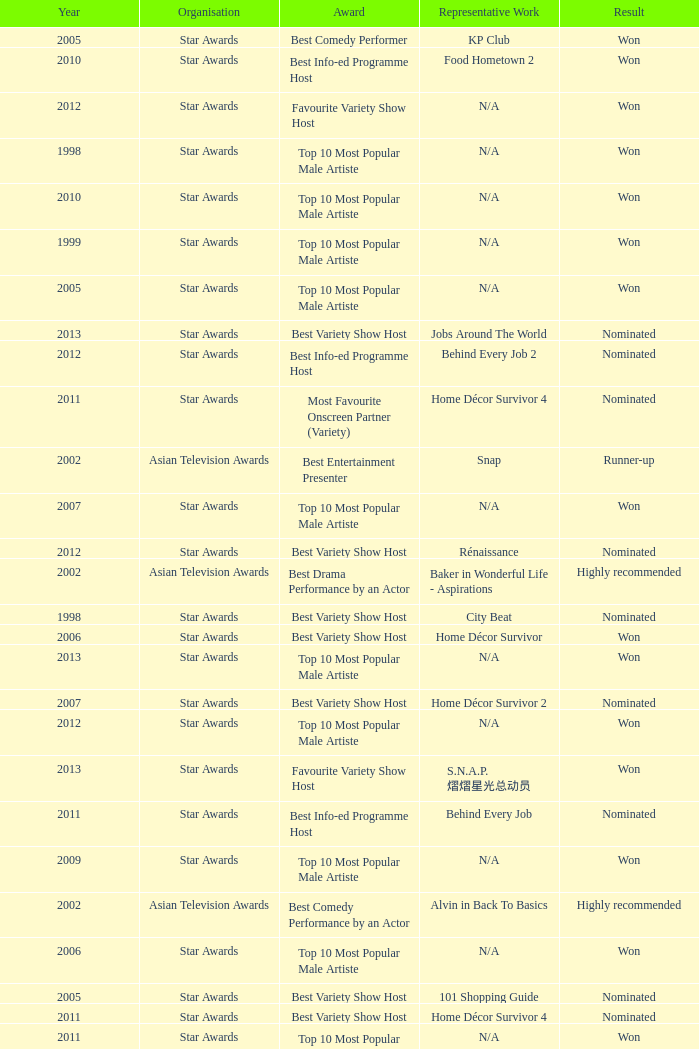Parse the full table. {'header': ['Year', 'Organisation', 'Award', 'Representative Work', 'Result'], 'rows': [['2005', 'Star Awards', 'Best Comedy Performer', 'KP Club', 'Won'], ['2010', 'Star Awards', 'Best Info-ed Programme Host', 'Food Hometown 2', 'Won'], ['2012', 'Star Awards', 'Favourite Variety Show Host', 'N/A', 'Won'], ['1998', 'Star Awards', 'Top 10 Most Popular Male Artiste', 'N/A', 'Won'], ['2010', 'Star Awards', 'Top 10 Most Popular Male Artiste', 'N/A', 'Won'], ['1999', 'Star Awards', 'Top 10 Most Popular Male Artiste', 'N/A', 'Won'], ['2005', 'Star Awards', 'Top 10 Most Popular Male Artiste', 'N/A', 'Won'], ['2013', 'Star Awards', 'Best Variety Show Host', 'Jobs Around The World', 'Nominated'], ['2012', 'Star Awards', 'Best Info-ed Programme Host', 'Behind Every Job 2', 'Nominated'], ['2011', 'Star Awards', 'Most Favourite Onscreen Partner (Variety)', 'Home Décor Survivor 4', 'Nominated'], ['2002', 'Asian Television Awards', 'Best Entertainment Presenter', 'Snap', 'Runner-up'], ['2007', 'Star Awards', 'Top 10 Most Popular Male Artiste', 'N/A', 'Won'], ['2012', 'Star Awards', 'Best Variety Show Host', 'Rénaissance', 'Nominated'], ['2002', 'Asian Television Awards', 'Best Drama Performance by an Actor', 'Baker in Wonderful Life - Aspirations', 'Highly recommended'], ['1998', 'Star Awards', 'Best Variety Show Host', 'City Beat', 'Nominated'], ['2006', 'Star Awards', 'Best Variety Show Host', 'Home Décor Survivor', 'Won'], ['2013', 'Star Awards', 'Top 10 Most Popular Male Artiste', 'N/A', 'Won'], ['2007', 'Star Awards', 'Best Variety Show Host', 'Home Décor Survivor 2', 'Nominated'], ['2012', 'Star Awards', 'Top 10 Most Popular Male Artiste', 'N/A', 'Won'], ['2013', 'Star Awards', 'Favourite Variety Show Host', 'S.N.A.P. 熠熠星光总动员', 'Won'], ['2011', 'Star Awards', 'Best Info-ed Programme Host', 'Behind Every Job', 'Nominated'], ['2009', 'Star Awards', 'Top 10 Most Popular Male Artiste', 'N/A', 'Won'], ['2002', 'Asian Television Awards', 'Best Comedy Performance by an Actor', 'Alvin in Back To Basics', 'Highly recommended'], ['2006', 'Star Awards', 'Top 10 Most Popular Male Artiste', 'N/A', 'Won'], ['2005', 'Star Awards', 'Best Variety Show Host', '101 Shopping Guide', 'Nominated'], ['2011', 'Star Awards', 'Best Variety Show Host', 'Home Décor Survivor 4', 'Nominated'], ['2011', 'Star Awards', 'Top 10 Most Popular Male Artiste', 'N/A', 'Won'], ['2013', 'Star Awards', 'Best Info-Ed Programme Host', 'Makan Unlimited', 'Nominated']]} What is the organisation in 2011 that was nominated and the award of best info-ed programme host? Star Awards. 